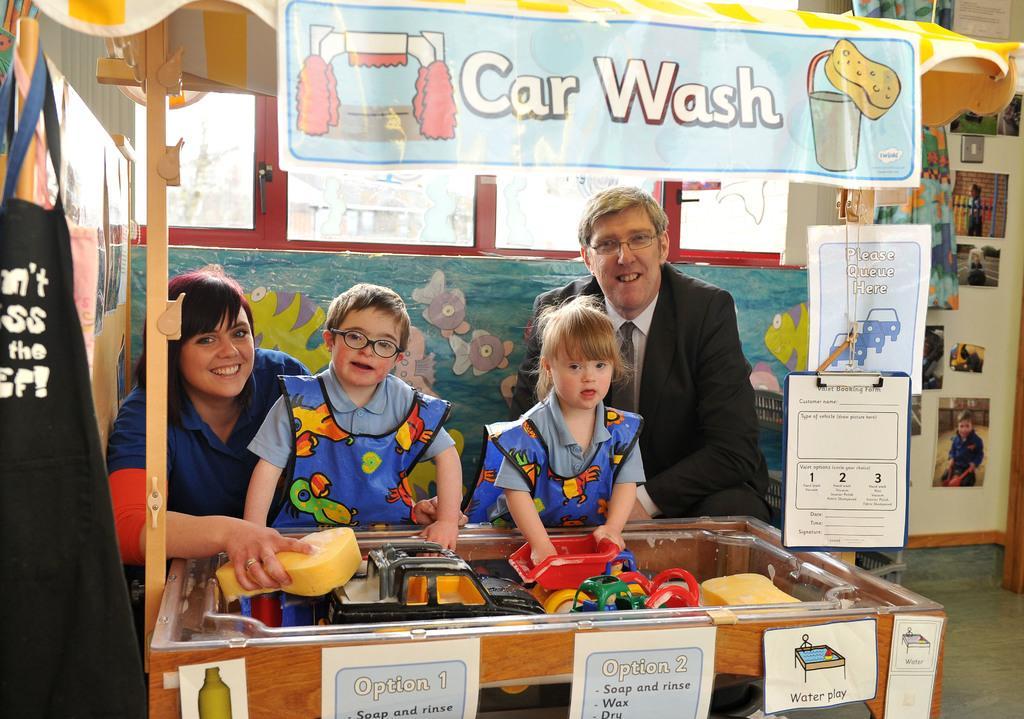Can you describe this image briefly? In this image I can see a stall to which I can see few boards which are blue in color and in the stall I can see two children wearing blue colored dress, a man wearing black blazer, white shirt and a woman wearing blue and red colored dress. In the background I can see the wall, few windows and few photos attached to the wall. 